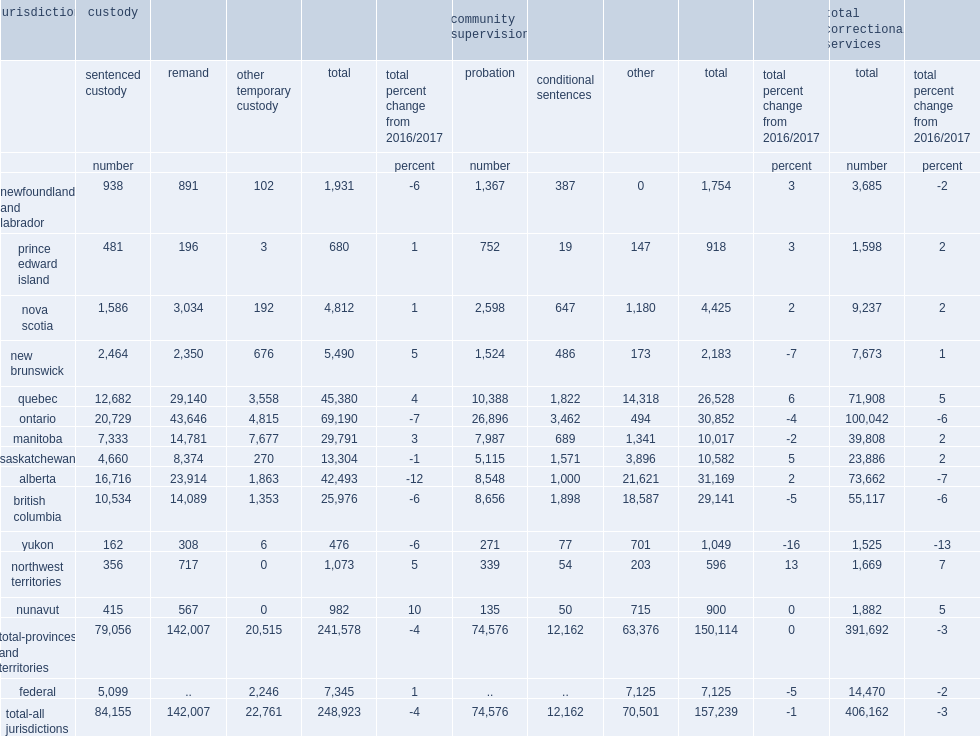How many admissions were there to provincial/territorial adult correctional services in 2017/2018? 391692.0. How many admissions were there to federal adult correctional services in 2017/2018? 14470.0. How many total admissions were there to adult correctional services in 2017/2018? 406162.0. What was the declines in the total number of admissions to adult correctional services from 2016/2017? 3. What was the declines in the number of provincial/territorial admissions to adult correctional services from 2016/2017? 3. What was the declines in the number of federal admissions to adult correctional services from 2016/2017? 2. What was the declines in admissions to custody overall from 2016/2017? 4. What was the declines in admissions to community supervision from 2016/2017? 1. What was the declines in the total number of admissions to adult correctional services in yukon from 2016/2017? 13. What was the change in the number of admissions to correctional services in the northwest territories from 2016/2017? 7.0. What was the change in the number of admissions to community supervision in the northwest territories from 2016/2017? 13.0. What was the change in admissions to custody from 2016/2017 at the federal level? 1.0. What was the declines in admissions to community supervision from 2016/2017 at the federal level? 5. 